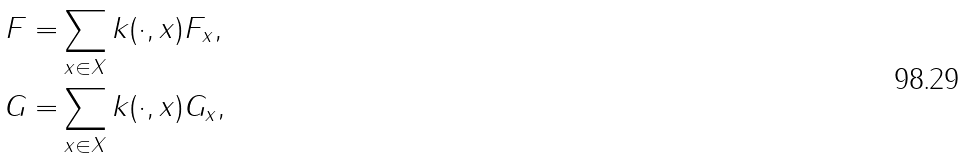<formula> <loc_0><loc_0><loc_500><loc_500>F = & \sum _ { x \in X } k ( \cdot , x ) F _ { x } , \\ G = & \sum _ { x \in X } k ( \cdot , x ) G _ { x } ,</formula> 